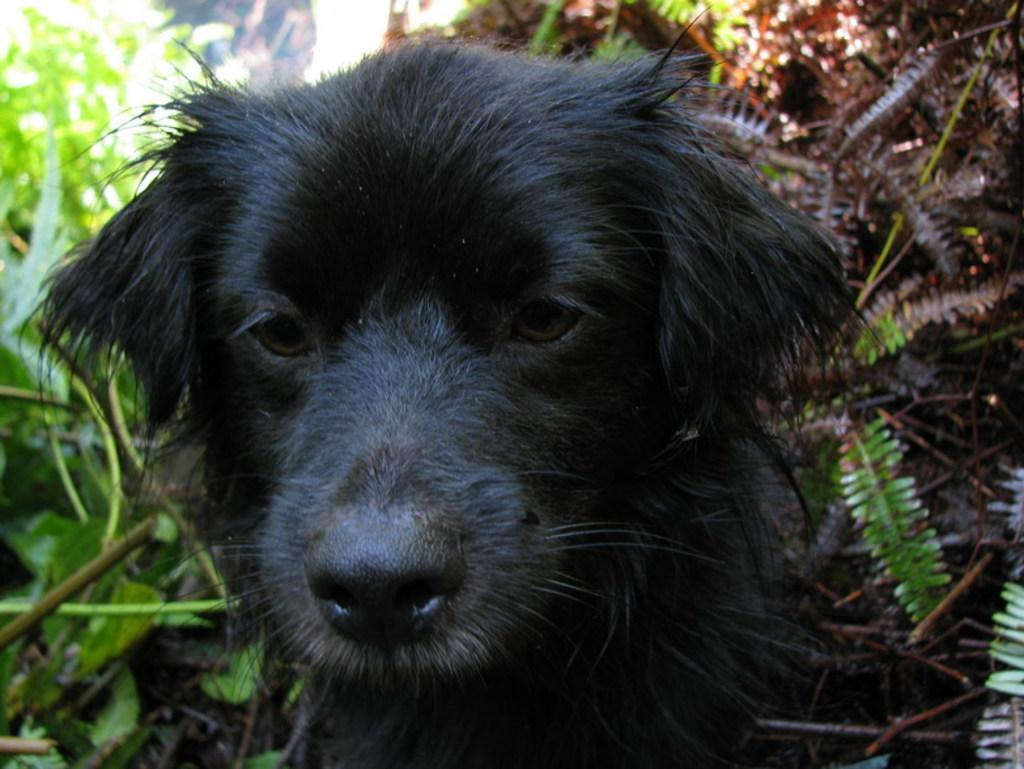What type of animal is in the image? There is a black color dog in the image. Where is the dog located in the image? The dog is in the plants. What type of pie is the dog eating in the image? There is no pie present in the image; the dog is in the plants. 